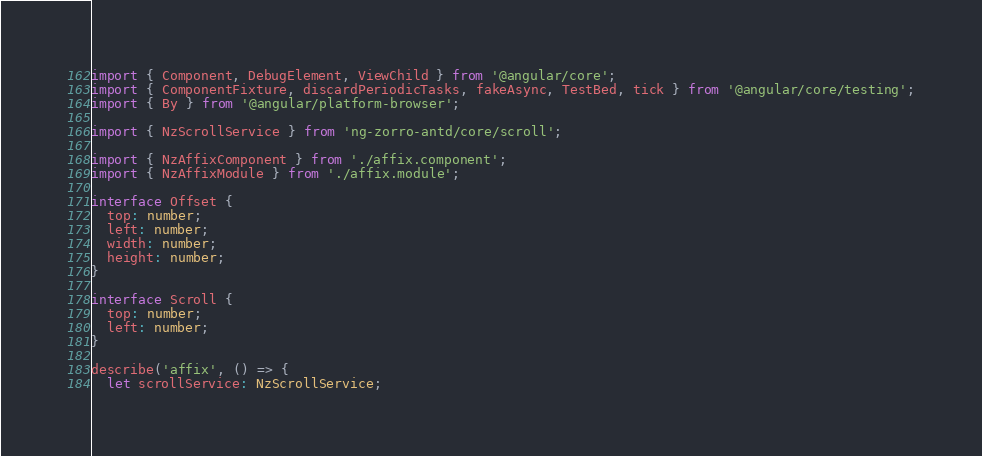<code> <loc_0><loc_0><loc_500><loc_500><_TypeScript_>import { Component, DebugElement, ViewChild } from '@angular/core';
import { ComponentFixture, discardPeriodicTasks, fakeAsync, TestBed, tick } from '@angular/core/testing';
import { By } from '@angular/platform-browser';

import { NzScrollService } from 'ng-zorro-antd/core/scroll';

import { NzAffixComponent } from './affix.component';
import { NzAffixModule } from './affix.module';

interface Offset {
  top: number;
  left: number;
  width: number;
  height: number;
}

interface Scroll {
  top: number;
  left: number;
}

describe('affix', () => {
  let scrollService: NzScrollService;</code> 